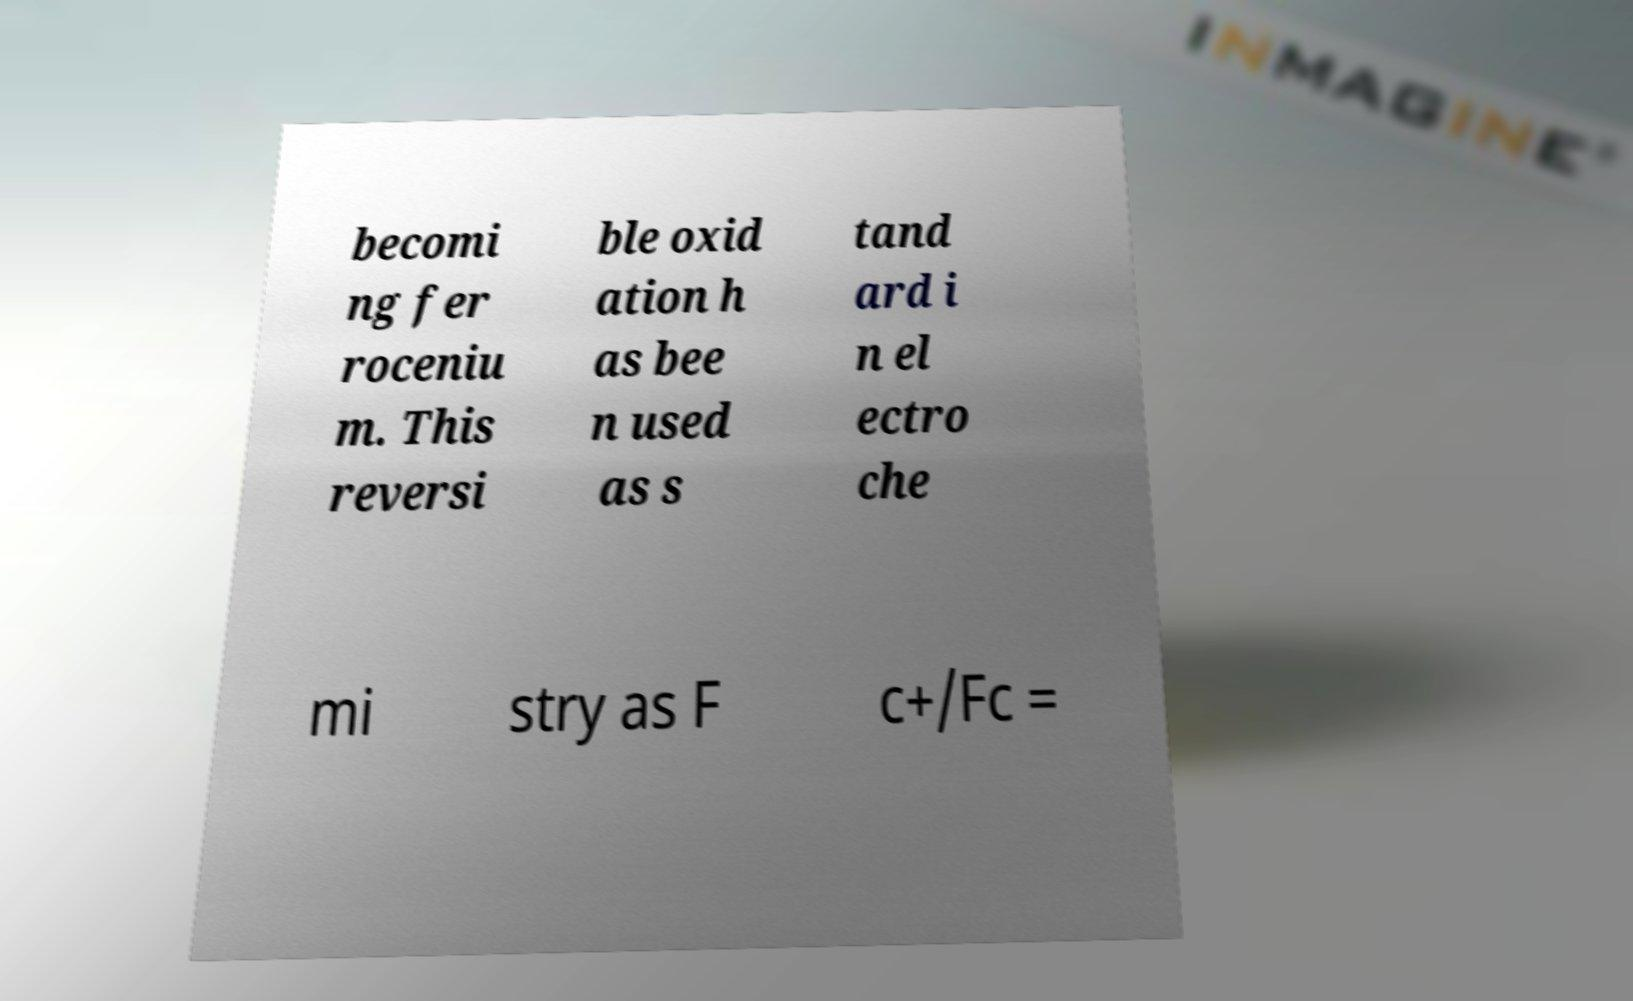For documentation purposes, I need the text within this image transcribed. Could you provide that? becomi ng fer roceniu m. This reversi ble oxid ation h as bee n used as s tand ard i n el ectro che mi stry as F c+/Fc = 